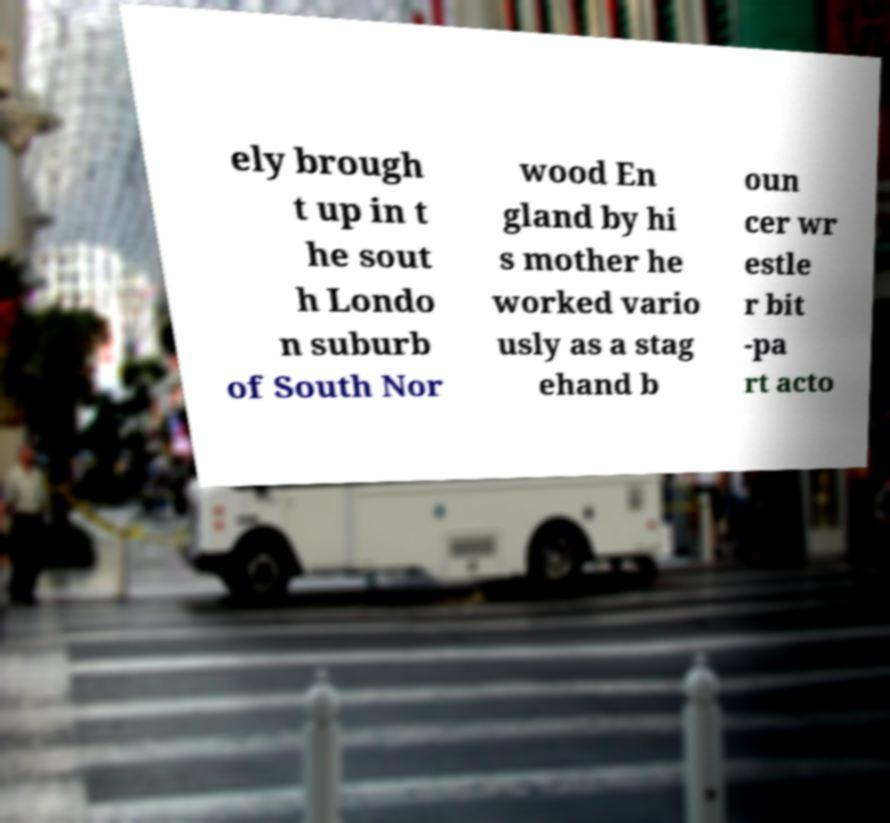Could you extract and type out the text from this image? ely brough t up in t he sout h Londo n suburb of South Nor wood En gland by hi s mother he worked vario usly as a stag ehand b oun cer wr estle r bit -pa rt acto 